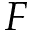Convert formula to latex. <formula><loc_0><loc_0><loc_500><loc_500>F</formula> 